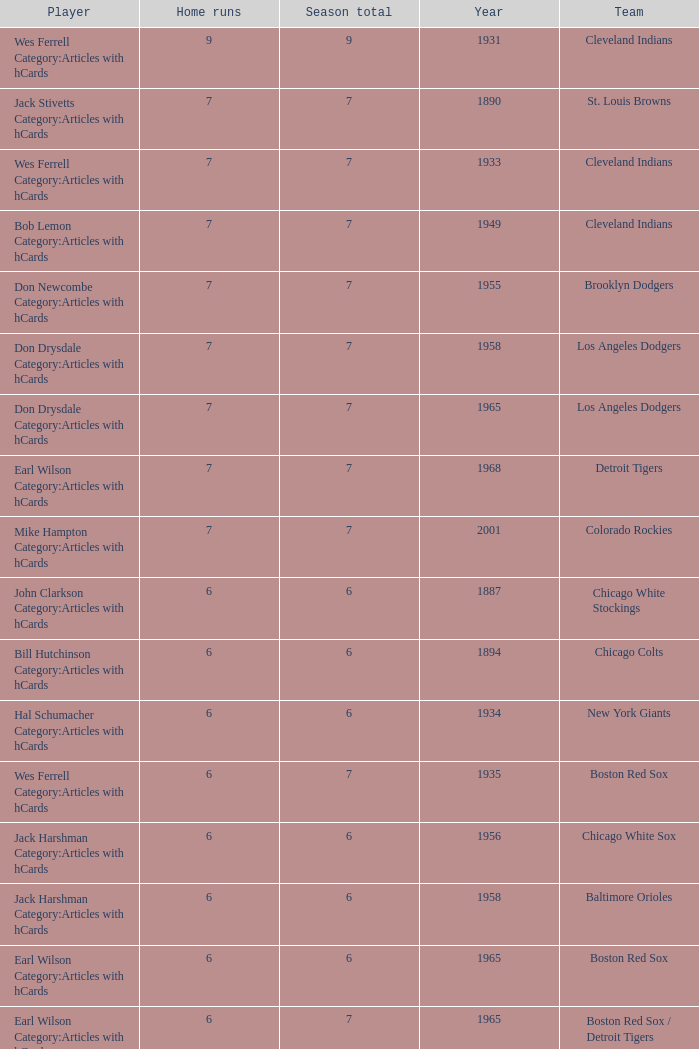Tell me the highest home runs for cleveland indians years before 1931 None. 